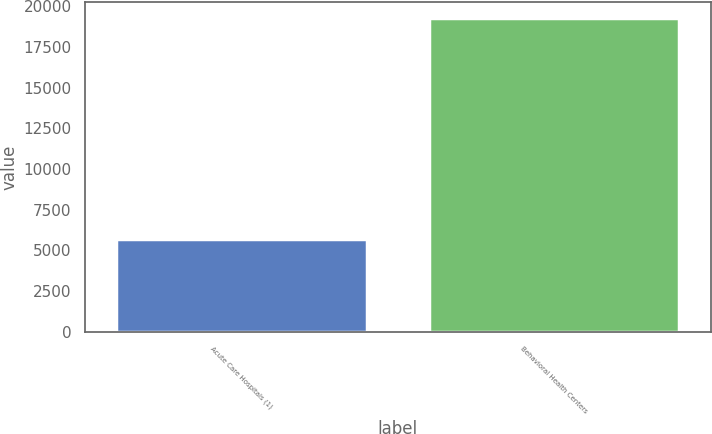Convert chart to OTSL. <chart><loc_0><loc_0><loc_500><loc_500><bar_chart><fcel>Acute Care Hospitals (1)<fcel>Behavioral Health Centers<nl><fcel>5726<fcel>19280<nl></chart> 